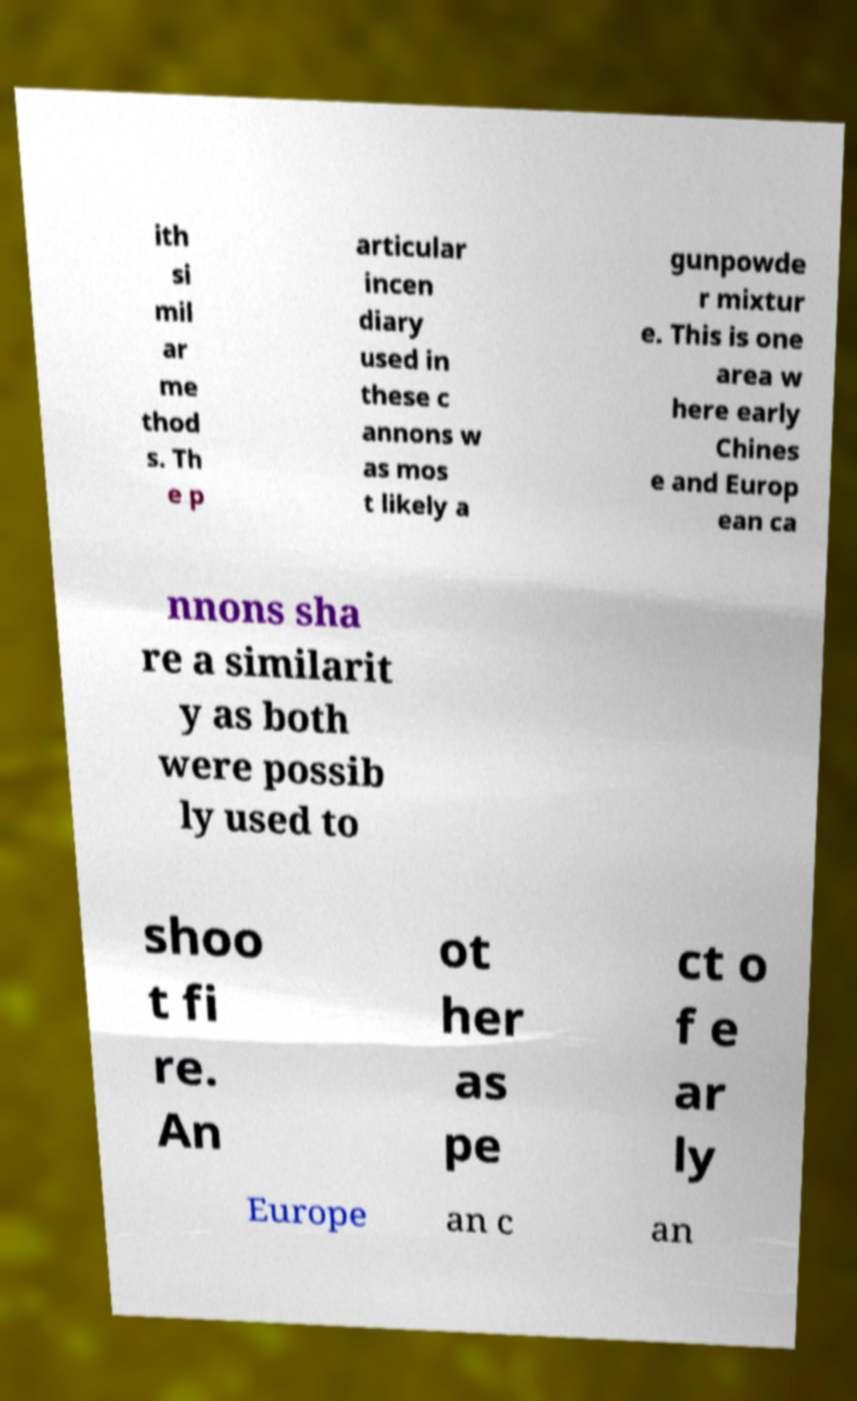Please identify and transcribe the text found in this image. ith si mil ar me thod s. Th e p articular incen diary used in these c annons w as mos t likely a gunpowde r mixtur e. This is one area w here early Chines e and Europ ean ca nnons sha re a similarit y as both were possib ly used to shoo t fi re. An ot her as pe ct o f e ar ly Europe an c an 